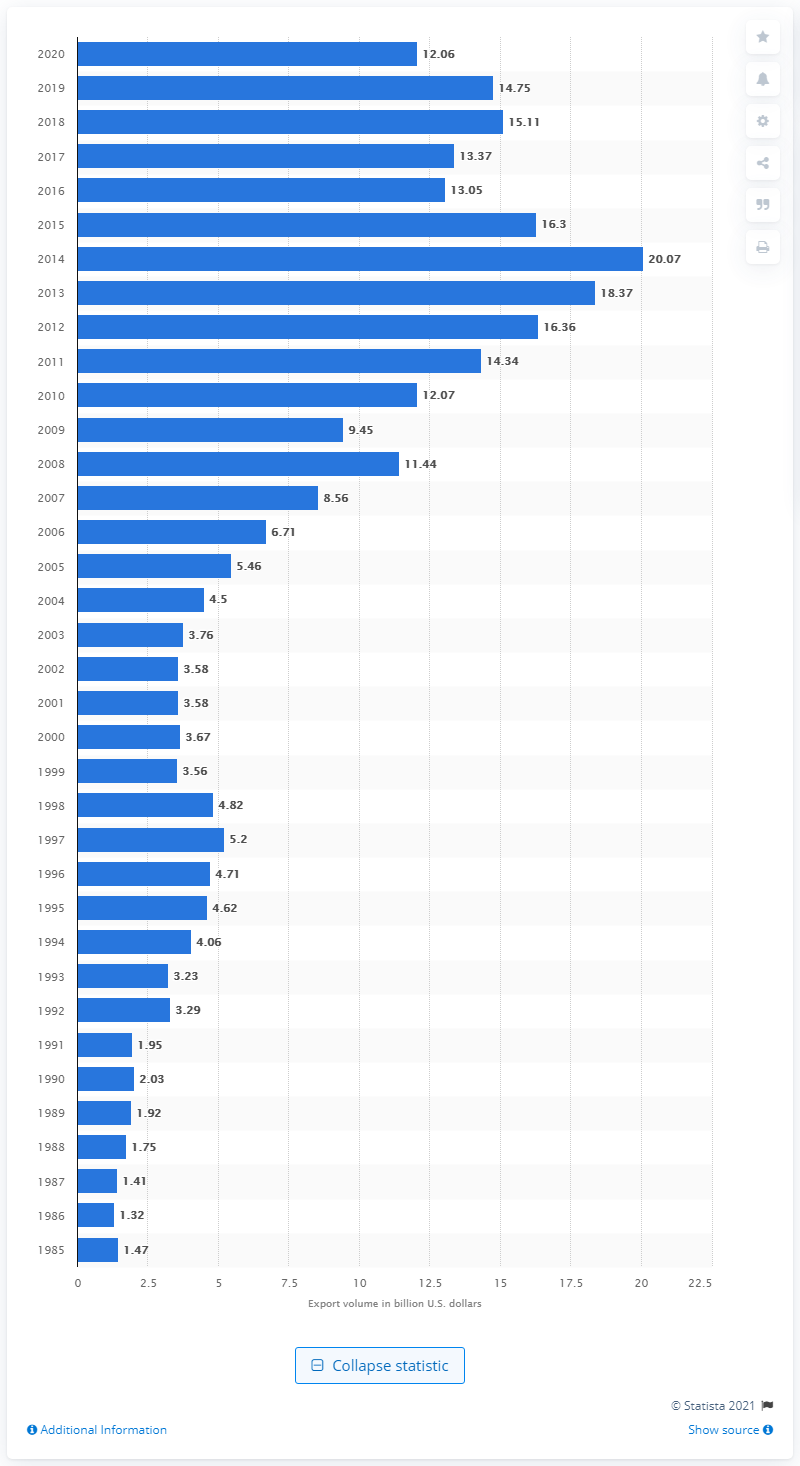How many dollars did the U.S. export to Colombia in 2020?
 12.06 